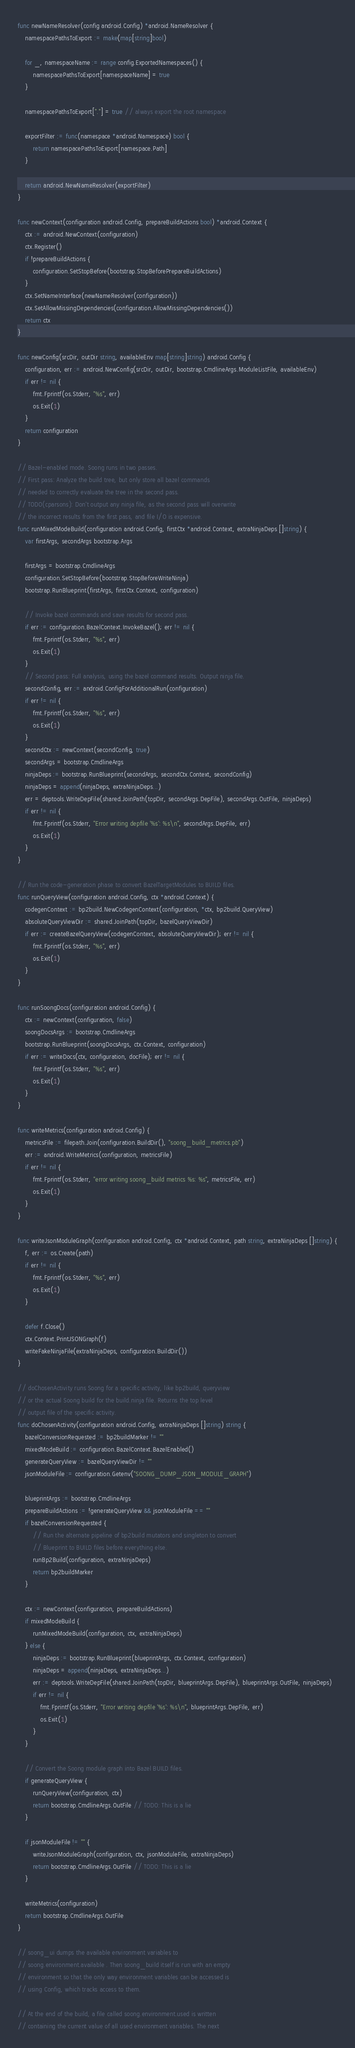<code> <loc_0><loc_0><loc_500><loc_500><_Go_>
func newNameResolver(config android.Config) *android.NameResolver {
	namespacePathsToExport := make(map[string]bool)

	for _, namespaceName := range config.ExportedNamespaces() {
		namespacePathsToExport[namespaceName] = true
	}

	namespacePathsToExport["."] = true // always export the root namespace

	exportFilter := func(namespace *android.Namespace) bool {
		return namespacePathsToExport[namespace.Path]
	}

	return android.NewNameResolver(exportFilter)
}

func newContext(configuration android.Config, prepareBuildActions bool) *android.Context {
	ctx := android.NewContext(configuration)
	ctx.Register()
	if !prepareBuildActions {
		configuration.SetStopBefore(bootstrap.StopBeforePrepareBuildActions)
	}
	ctx.SetNameInterface(newNameResolver(configuration))
	ctx.SetAllowMissingDependencies(configuration.AllowMissingDependencies())
	return ctx
}

func newConfig(srcDir, outDir string, availableEnv map[string]string) android.Config {
	configuration, err := android.NewConfig(srcDir, outDir, bootstrap.CmdlineArgs.ModuleListFile, availableEnv)
	if err != nil {
		fmt.Fprintf(os.Stderr, "%s", err)
		os.Exit(1)
	}
	return configuration
}

// Bazel-enabled mode. Soong runs in two passes.
// First pass: Analyze the build tree, but only store all bazel commands
// needed to correctly evaluate the tree in the second pass.
// TODO(cparsons): Don't output any ninja file, as the second pass will overwrite
// the incorrect results from the first pass, and file I/O is expensive.
func runMixedModeBuild(configuration android.Config, firstCtx *android.Context, extraNinjaDeps []string) {
	var firstArgs, secondArgs bootstrap.Args

	firstArgs = bootstrap.CmdlineArgs
	configuration.SetStopBefore(bootstrap.StopBeforeWriteNinja)
	bootstrap.RunBlueprint(firstArgs, firstCtx.Context, configuration)

	// Invoke bazel commands and save results for second pass.
	if err := configuration.BazelContext.InvokeBazel(); err != nil {
		fmt.Fprintf(os.Stderr, "%s", err)
		os.Exit(1)
	}
	// Second pass: Full analysis, using the bazel command results. Output ninja file.
	secondConfig, err := android.ConfigForAdditionalRun(configuration)
	if err != nil {
		fmt.Fprintf(os.Stderr, "%s", err)
		os.Exit(1)
	}
	secondCtx := newContext(secondConfig, true)
	secondArgs = bootstrap.CmdlineArgs
	ninjaDeps := bootstrap.RunBlueprint(secondArgs, secondCtx.Context, secondConfig)
	ninjaDeps = append(ninjaDeps, extraNinjaDeps...)
	err = deptools.WriteDepFile(shared.JoinPath(topDir, secondArgs.DepFile), secondArgs.OutFile, ninjaDeps)
	if err != nil {
		fmt.Fprintf(os.Stderr, "Error writing depfile '%s': %s\n", secondArgs.DepFile, err)
		os.Exit(1)
	}
}

// Run the code-generation phase to convert BazelTargetModules to BUILD files.
func runQueryView(configuration android.Config, ctx *android.Context) {
	codegenContext := bp2build.NewCodegenContext(configuration, *ctx, bp2build.QueryView)
	absoluteQueryViewDir := shared.JoinPath(topDir, bazelQueryViewDir)
	if err := createBazelQueryView(codegenContext, absoluteQueryViewDir); err != nil {
		fmt.Fprintf(os.Stderr, "%s", err)
		os.Exit(1)
	}
}

func runSoongDocs(configuration android.Config) {
	ctx := newContext(configuration, false)
	soongDocsArgs := bootstrap.CmdlineArgs
	bootstrap.RunBlueprint(soongDocsArgs, ctx.Context, configuration)
	if err := writeDocs(ctx, configuration, docFile); err != nil {
		fmt.Fprintf(os.Stderr, "%s", err)
		os.Exit(1)
	}
}

func writeMetrics(configuration android.Config) {
	metricsFile := filepath.Join(configuration.BuildDir(), "soong_build_metrics.pb")
	err := android.WriteMetrics(configuration, metricsFile)
	if err != nil {
		fmt.Fprintf(os.Stderr, "error writing soong_build metrics %s: %s", metricsFile, err)
		os.Exit(1)
	}
}

func writeJsonModuleGraph(configuration android.Config, ctx *android.Context, path string, extraNinjaDeps []string) {
	f, err := os.Create(path)
	if err != nil {
		fmt.Fprintf(os.Stderr, "%s", err)
		os.Exit(1)
	}

	defer f.Close()
	ctx.Context.PrintJSONGraph(f)
	writeFakeNinjaFile(extraNinjaDeps, configuration.BuildDir())
}

// doChosenActivity runs Soong for a specific activity, like bp2build, queryview
// or the actual Soong build for the build.ninja file. Returns the top level
// output file of the specific activity.
func doChosenActivity(configuration android.Config, extraNinjaDeps []string) string {
	bazelConversionRequested := bp2buildMarker != ""
	mixedModeBuild := configuration.BazelContext.BazelEnabled()
	generateQueryView := bazelQueryViewDir != ""
	jsonModuleFile := configuration.Getenv("SOONG_DUMP_JSON_MODULE_GRAPH")

	blueprintArgs := bootstrap.CmdlineArgs
	prepareBuildActions := !generateQueryView && jsonModuleFile == ""
	if bazelConversionRequested {
		// Run the alternate pipeline of bp2build mutators and singleton to convert
		// Blueprint to BUILD files before everything else.
		runBp2Build(configuration, extraNinjaDeps)
		return bp2buildMarker
	}

	ctx := newContext(configuration, prepareBuildActions)
	if mixedModeBuild {
		runMixedModeBuild(configuration, ctx, extraNinjaDeps)
	} else {
		ninjaDeps := bootstrap.RunBlueprint(blueprintArgs, ctx.Context, configuration)
		ninjaDeps = append(ninjaDeps, extraNinjaDeps...)
		err := deptools.WriteDepFile(shared.JoinPath(topDir, blueprintArgs.DepFile), blueprintArgs.OutFile, ninjaDeps)
		if err != nil {
			fmt.Fprintf(os.Stderr, "Error writing depfile '%s': %s\n", blueprintArgs.DepFile, err)
			os.Exit(1)
		}
	}

	// Convert the Soong module graph into Bazel BUILD files.
	if generateQueryView {
		runQueryView(configuration, ctx)
		return bootstrap.CmdlineArgs.OutFile // TODO: This is a lie
	}

	if jsonModuleFile != "" {
		writeJsonModuleGraph(configuration, ctx, jsonModuleFile, extraNinjaDeps)
		return bootstrap.CmdlineArgs.OutFile // TODO: This is a lie
	}

	writeMetrics(configuration)
	return bootstrap.CmdlineArgs.OutFile
}

// soong_ui dumps the available environment variables to
// soong.environment.available . Then soong_build itself is run with an empty
// environment so that the only way environment variables can be accessed is
// using Config, which tracks access to them.

// At the end of the build, a file called soong.environment.used is written
// containing the current value of all used environment variables. The next</code> 